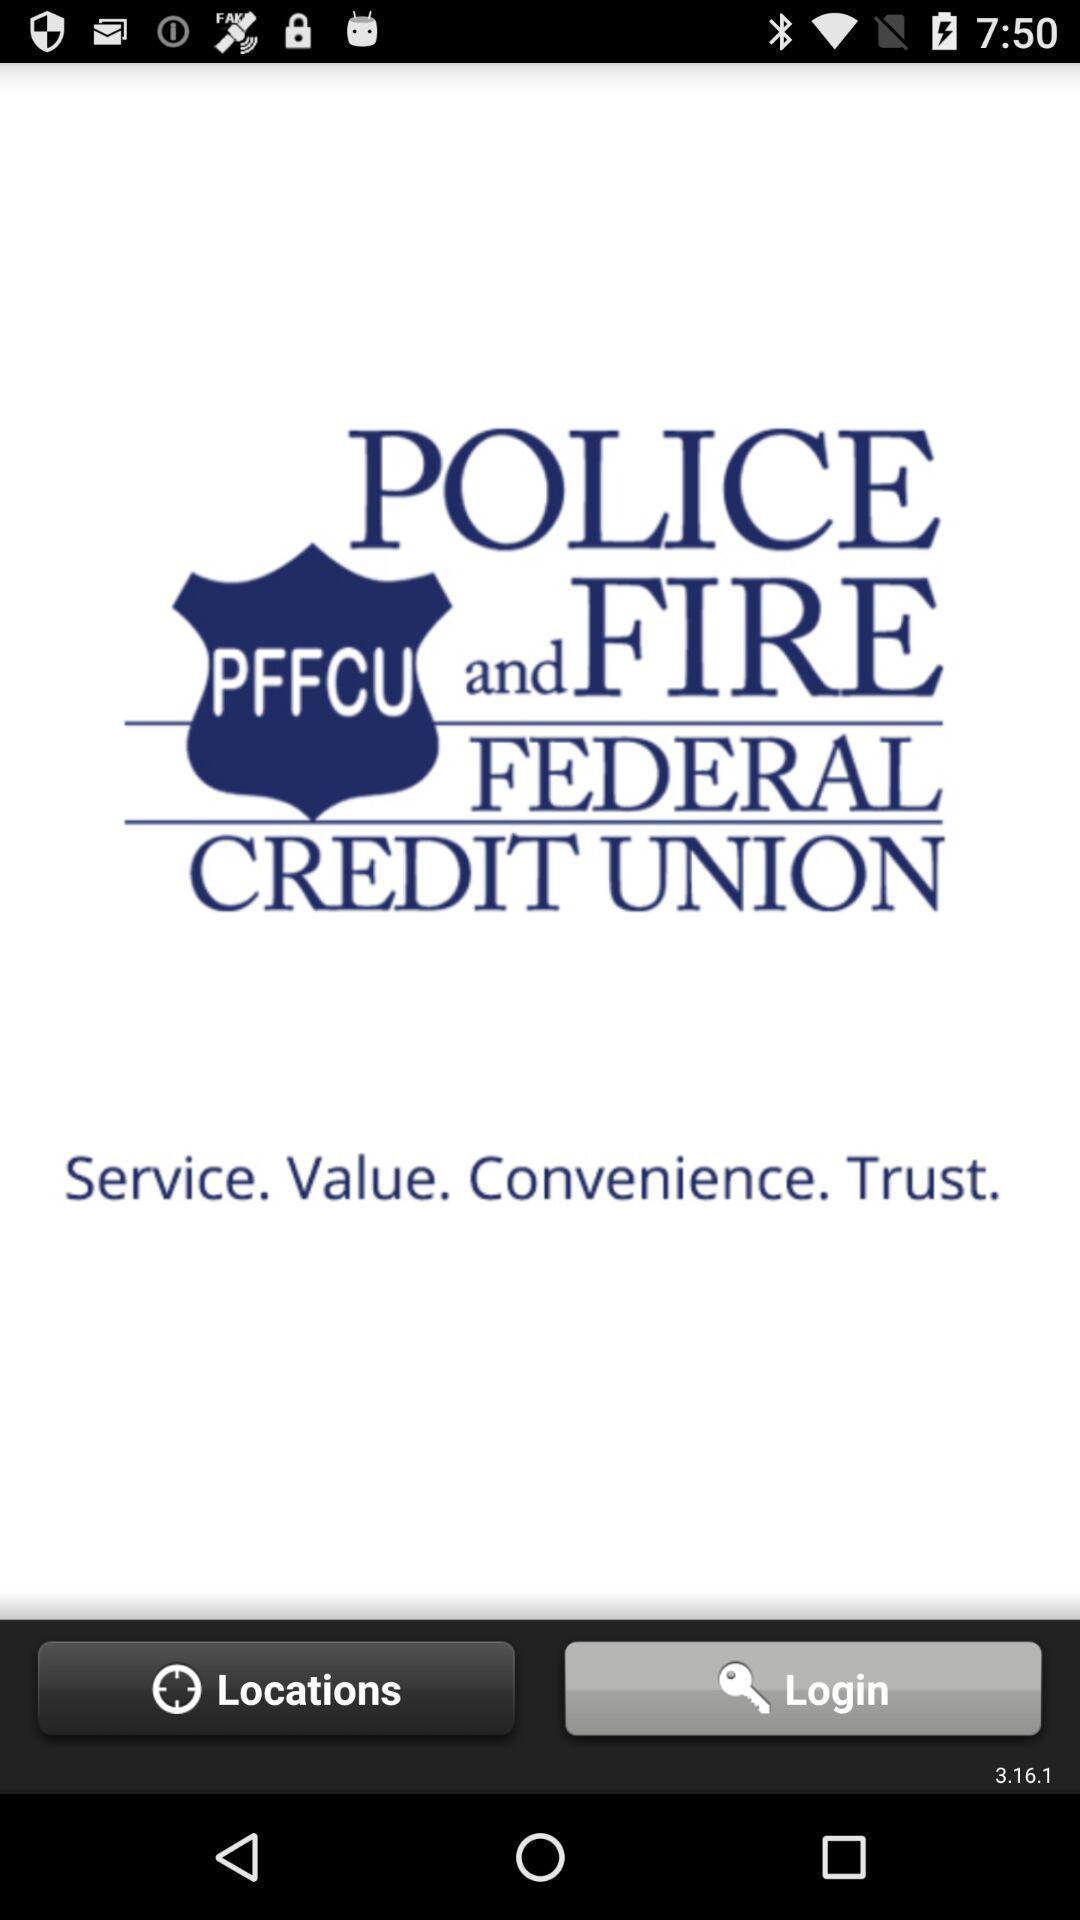Provide a detailed account of this screenshot. Screen displaying login page of a finance application. 